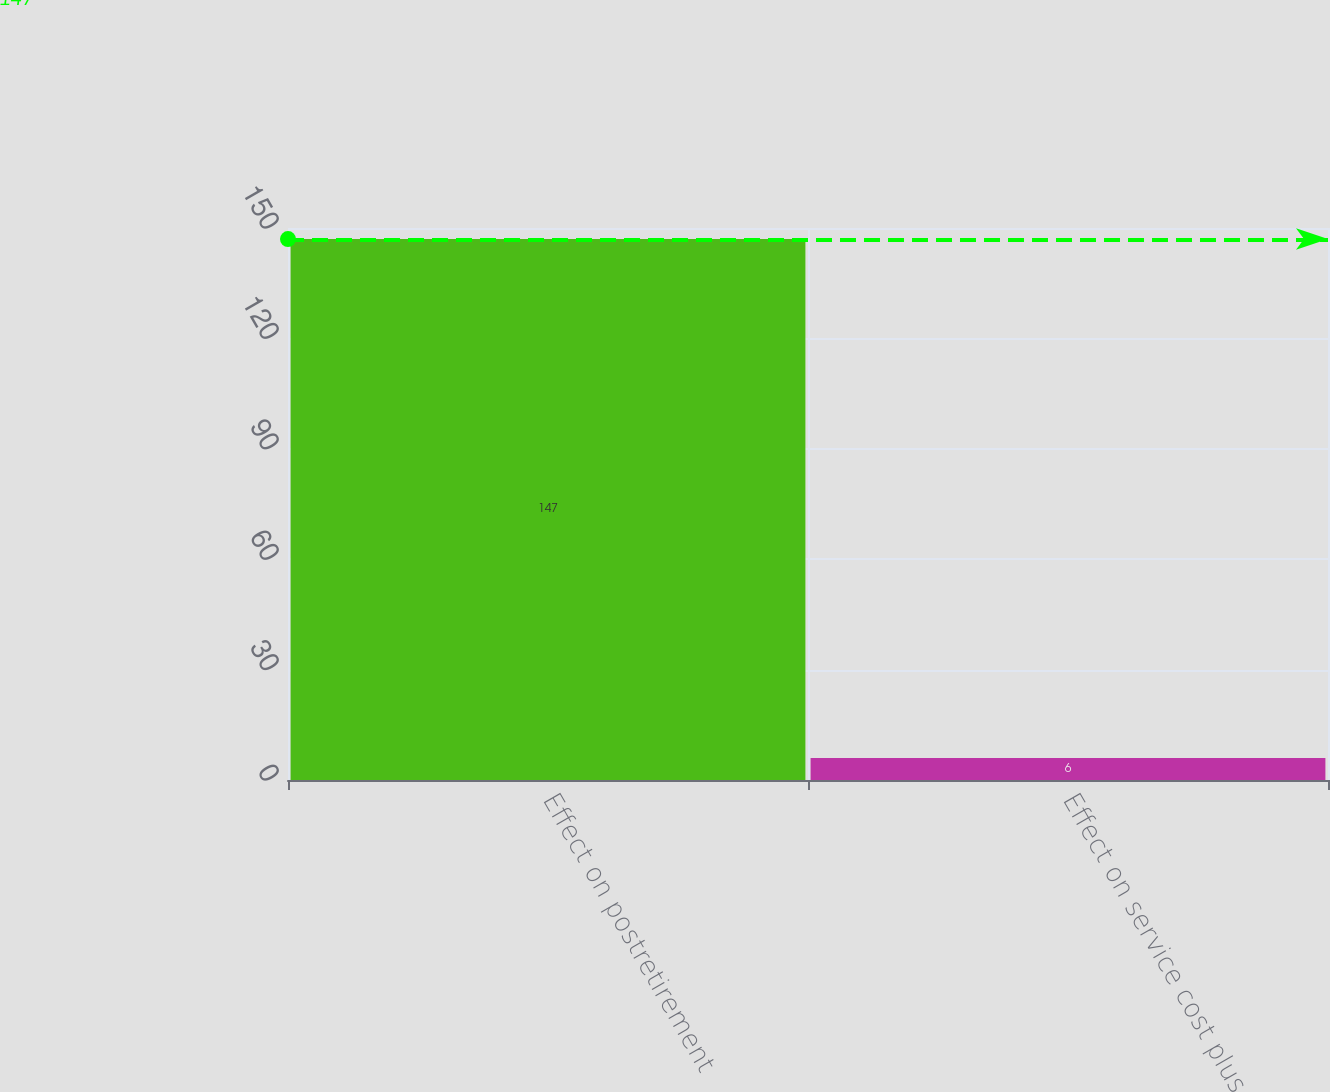Convert chart. <chart><loc_0><loc_0><loc_500><loc_500><bar_chart><fcel>Effect on postretirement<fcel>Effect on service cost plus<nl><fcel>147<fcel>6<nl></chart> 